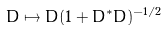Convert formula to latex. <formula><loc_0><loc_0><loc_500><loc_500>D \mapsto D ( 1 + D ^ { * } D ) ^ { - 1 / 2 }</formula> 